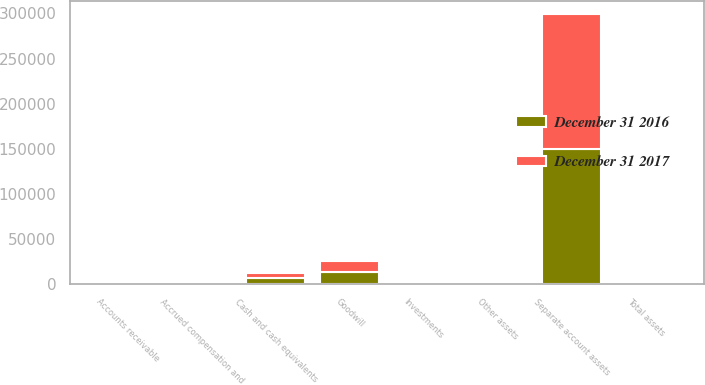Convert chart to OTSL. <chart><loc_0><loc_0><loc_500><loc_500><stacked_bar_chart><ecel><fcel>Cash and cash equivalents<fcel>Accounts receivable<fcel>Investments<fcel>Other assets<fcel>Separate account assets<fcel>Goodwill<fcel>Total assets<fcel>Accrued compensation and<nl><fcel>December 31 2016<fcel>6894<fcel>2699<fcel>1981<fcel>66<fcel>149937<fcel>13220<fcel>2426<fcel>2153<nl><fcel>December 31 2017<fcel>6091<fcel>2115<fcel>1595<fcel>63<fcel>149089<fcel>13118<fcel>2426<fcel>1880<nl></chart> 